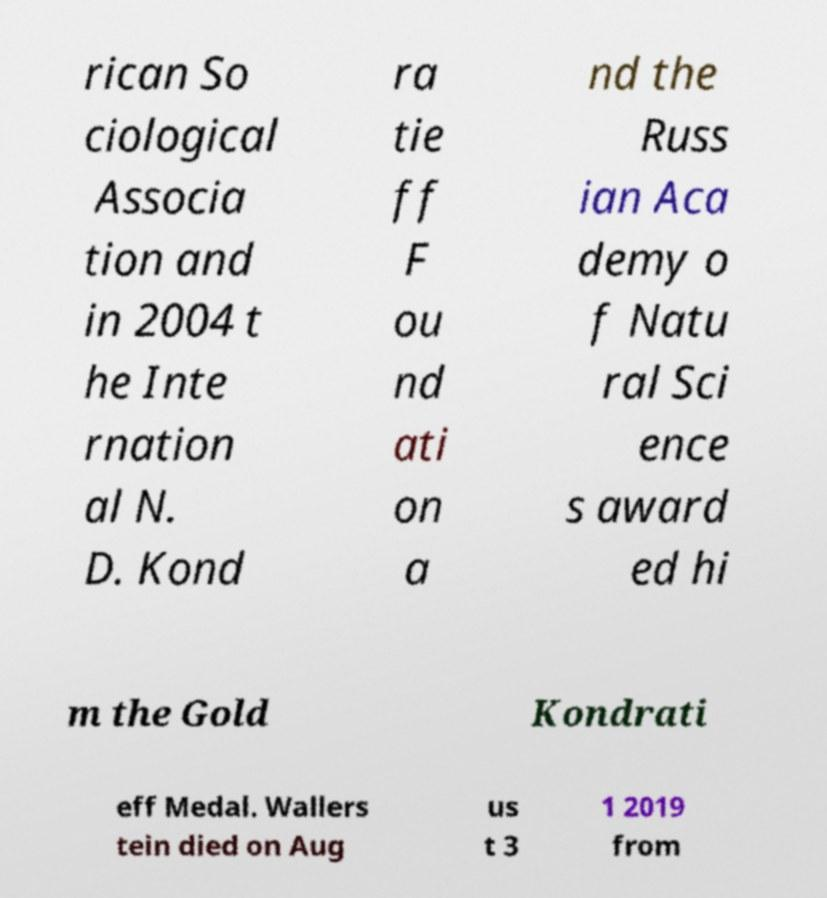Could you extract and type out the text from this image? rican So ciological Associa tion and in 2004 t he Inte rnation al N. D. Kond ra tie ff F ou nd ati on a nd the Russ ian Aca demy o f Natu ral Sci ence s award ed hi m the Gold Kondrati eff Medal. Wallers tein died on Aug us t 3 1 2019 from 